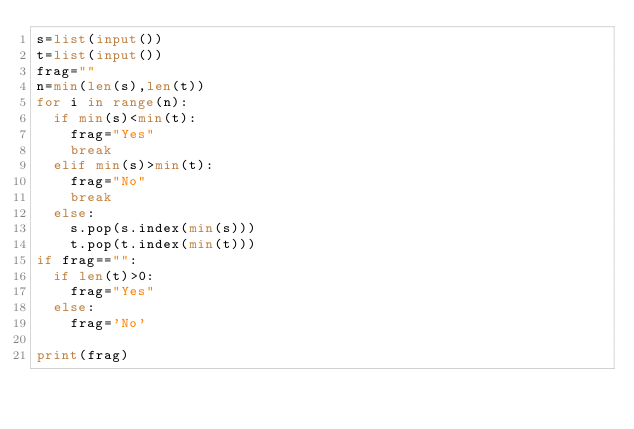Convert code to text. <code><loc_0><loc_0><loc_500><loc_500><_Python_>s=list(input())
t=list(input())
frag=""
n=min(len(s),len(t))
for i in range(n):
  if min(s)<min(t):
    frag="Yes"
    break
  elif min(s)>min(t):
    frag="No"
    break
  else:
    s.pop(s.index(min(s)))
    t.pop(t.index(min(t)))
if frag=="":
  if len(t)>0:
    frag="Yes"
  else:
    frag='No'

print(frag)</code> 